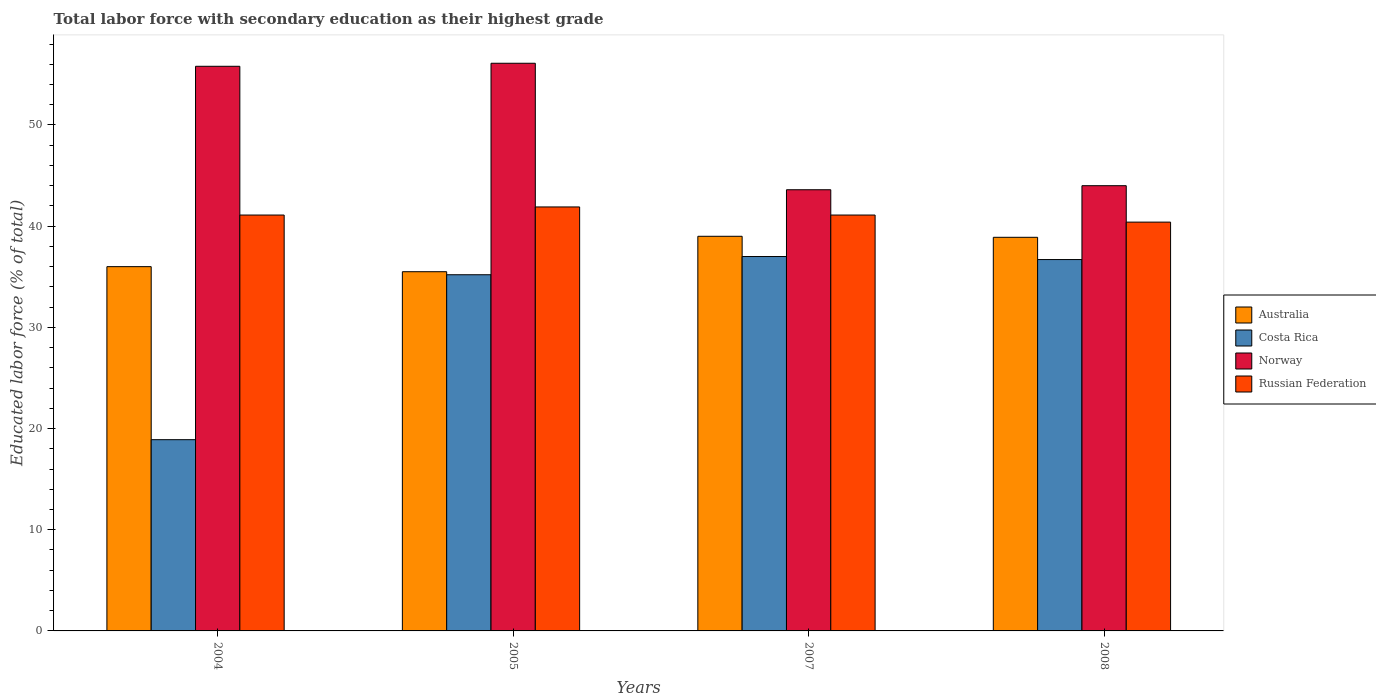How many different coloured bars are there?
Give a very brief answer. 4. How many groups of bars are there?
Provide a succinct answer. 4. Are the number of bars per tick equal to the number of legend labels?
Provide a succinct answer. Yes. How many bars are there on the 3rd tick from the left?
Your answer should be very brief. 4. How many bars are there on the 1st tick from the right?
Provide a succinct answer. 4. What is the label of the 3rd group of bars from the left?
Give a very brief answer. 2007. In how many cases, is the number of bars for a given year not equal to the number of legend labels?
Offer a very short reply. 0. What is the percentage of total labor force with primary education in Australia in 2008?
Ensure brevity in your answer.  38.9. Across all years, what is the maximum percentage of total labor force with primary education in Costa Rica?
Offer a terse response. 37. Across all years, what is the minimum percentage of total labor force with primary education in Russian Federation?
Provide a short and direct response. 40.4. In which year was the percentage of total labor force with primary education in Costa Rica maximum?
Make the answer very short. 2007. What is the total percentage of total labor force with primary education in Russian Federation in the graph?
Give a very brief answer. 164.5. What is the difference between the percentage of total labor force with primary education in Costa Rica in 2004 and that in 2008?
Your answer should be very brief. -17.8. What is the difference between the percentage of total labor force with primary education in Australia in 2008 and the percentage of total labor force with primary education in Norway in 2005?
Your answer should be compact. -17.2. What is the average percentage of total labor force with primary education in Australia per year?
Give a very brief answer. 37.35. In the year 2004, what is the difference between the percentage of total labor force with primary education in Australia and percentage of total labor force with primary education in Norway?
Provide a succinct answer. -19.8. In how many years, is the percentage of total labor force with primary education in Costa Rica greater than 18 %?
Your answer should be compact. 4. What is the ratio of the percentage of total labor force with primary education in Russian Federation in 2005 to that in 2007?
Your answer should be compact. 1.02. Is the difference between the percentage of total labor force with primary education in Australia in 2005 and 2008 greater than the difference between the percentage of total labor force with primary education in Norway in 2005 and 2008?
Offer a terse response. No. What is the difference between the highest and the second highest percentage of total labor force with primary education in Russian Federation?
Give a very brief answer. 0.8. What is the difference between the highest and the lowest percentage of total labor force with primary education in Norway?
Your response must be concise. 12.5. In how many years, is the percentage of total labor force with primary education in Australia greater than the average percentage of total labor force with primary education in Australia taken over all years?
Ensure brevity in your answer.  2. Is the sum of the percentage of total labor force with primary education in Norway in 2004 and 2005 greater than the maximum percentage of total labor force with primary education in Australia across all years?
Ensure brevity in your answer.  Yes. Is it the case that in every year, the sum of the percentage of total labor force with primary education in Australia and percentage of total labor force with primary education in Russian Federation is greater than the sum of percentage of total labor force with primary education in Costa Rica and percentage of total labor force with primary education in Norway?
Provide a short and direct response. No. What does the 3rd bar from the left in 2008 represents?
Keep it short and to the point. Norway. What does the 1st bar from the right in 2007 represents?
Give a very brief answer. Russian Federation. Is it the case that in every year, the sum of the percentage of total labor force with primary education in Costa Rica and percentage of total labor force with primary education in Australia is greater than the percentage of total labor force with primary education in Norway?
Make the answer very short. No. How many bars are there?
Keep it short and to the point. 16. How many years are there in the graph?
Offer a very short reply. 4. What is the difference between two consecutive major ticks on the Y-axis?
Your response must be concise. 10. Does the graph contain any zero values?
Offer a terse response. No. Does the graph contain grids?
Make the answer very short. No. Where does the legend appear in the graph?
Keep it short and to the point. Center right. How many legend labels are there?
Your response must be concise. 4. How are the legend labels stacked?
Offer a very short reply. Vertical. What is the title of the graph?
Your answer should be compact. Total labor force with secondary education as their highest grade. What is the label or title of the X-axis?
Offer a very short reply. Years. What is the label or title of the Y-axis?
Your response must be concise. Educated labor force (% of total). What is the Educated labor force (% of total) in Costa Rica in 2004?
Your answer should be compact. 18.9. What is the Educated labor force (% of total) in Norway in 2004?
Keep it short and to the point. 55.8. What is the Educated labor force (% of total) of Russian Federation in 2004?
Your answer should be compact. 41.1. What is the Educated labor force (% of total) in Australia in 2005?
Offer a terse response. 35.5. What is the Educated labor force (% of total) of Costa Rica in 2005?
Your answer should be very brief. 35.2. What is the Educated labor force (% of total) in Norway in 2005?
Give a very brief answer. 56.1. What is the Educated labor force (% of total) of Russian Federation in 2005?
Offer a terse response. 41.9. What is the Educated labor force (% of total) in Norway in 2007?
Give a very brief answer. 43.6. What is the Educated labor force (% of total) in Russian Federation in 2007?
Give a very brief answer. 41.1. What is the Educated labor force (% of total) in Australia in 2008?
Your response must be concise. 38.9. What is the Educated labor force (% of total) in Costa Rica in 2008?
Provide a short and direct response. 36.7. What is the Educated labor force (% of total) in Norway in 2008?
Offer a terse response. 44. What is the Educated labor force (% of total) in Russian Federation in 2008?
Offer a terse response. 40.4. Across all years, what is the maximum Educated labor force (% of total) of Australia?
Offer a very short reply. 39. Across all years, what is the maximum Educated labor force (% of total) in Norway?
Keep it short and to the point. 56.1. Across all years, what is the maximum Educated labor force (% of total) of Russian Federation?
Your response must be concise. 41.9. Across all years, what is the minimum Educated labor force (% of total) of Australia?
Make the answer very short. 35.5. Across all years, what is the minimum Educated labor force (% of total) of Costa Rica?
Keep it short and to the point. 18.9. Across all years, what is the minimum Educated labor force (% of total) in Norway?
Your response must be concise. 43.6. Across all years, what is the minimum Educated labor force (% of total) in Russian Federation?
Provide a succinct answer. 40.4. What is the total Educated labor force (% of total) of Australia in the graph?
Your answer should be compact. 149.4. What is the total Educated labor force (% of total) of Costa Rica in the graph?
Provide a succinct answer. 127.8. What is the total Educated labor force (% of total) in Norway in the graph?
Ensure brevity in your answer.  199.5. What is the total Educated labor force (% of total) of Russian Federation in the graph?
Provide a succinct answer. 164.5. What is the difference between the Educated labor force (% of total) of Australia in 2004 and that in 2005?
Make the answer very short. 0.5. What is the difference between the Educated labor force (% of total) in Costa Rica in 2004 and that in 2005?
Give a very brief answer. -16.3. What is the difference between the Educated labor force (% of total) of Norway in 2004 and that in 2005?
Make the answer very short. -0.3. What is the difference between the Educated labor force (% of total) in Australia in 2004 and that in 2007?
Provide a short and direct response. -3. What is the difference between the Educated labor force (% of total) of Costa Rica in 2004 and that in 2007?
Give a very brief answer. -18.1. What is the difference between the Educated labor force (% of total) of Norway in 2004 and that in 2007?
Offer a terse response. 12.2. What is the difference between the Educated labor force (% of total) in Russian Federation in 2004 and that in 2007?
Keep it short and to the point. 0. What is the difference between the Educated labor force (% of total) in Australia in 2004 and that in 2008?
Keep it short and to the point. -2.9. What is the difference between the Educated labor force (% of total) in Costa Rica in 2004 and that in 2008?
Ensure brevity in your answer.  -17.8. What is the difference between the Educated labor force (% of total) in Russian Federation in 2004 and that in 2008?
Provide a succinct answer. 0.7. What is the difference between the Educated labor force (% of total) in Costa Rica in 2005 and that in 2007?
Offer a terse response. -1.8. What is the difference between the Educated labor force (% of total) in Russian Federation in 2005 and that in 2007?
Your answer should be very brief. 0.8. What is the difference between the Educated labor force (% of total) of Australia in 2007 and that in 2008?
Offer a very short reply. 0.1. What is the difference between the Educated labor force (% of total) of Russian Federation in 2007 and that in 2008?
Offer a terse response. 0.7. What is the difference between the Educated labor force (% of total) in Australia in 2004 and the Educated labor force (% of total) in Norway in 2005?
Offer a very short reply. -20.1. What is the difference between the Educated labor force (% of total) in Australia in 2004 and the Educated labor force (% of total) in Russian Federation in 2005?
Give a very brief answer. -5.9. What is the difference between the Educated labor force (% of total) of Costa Rica in 2004 and the Educated labor force (% of total) of Norway in 2005?
Provide a succinct answer. -37.2. What is the difference between the Educated labor force (% of total) in Costa Rica in 2004 and the Educated labor force (% of total) in Russian Federation in 2005?
Offer a very short reply. -23. What is the difference between the Educated labor force (% of total) of Norway in 2004 and the Educated labor force (% of total) of Russian Federation in 2005?
Your answer should be very brief. 13.9. What is the difference between the Educated labor force (% of total) in Costa Rica in 2004 and the Educated labor force (% of total) in Norway in 2007?
Offer a very short reply. -24.7. What is the difference between the Educated labor force (% of total) in Costa Rica in 2004 and the Educated labor force (% of total) in Russian Federation in 2007?
Your response must be concise. -22.2. What is the difference between the Educated labor force (% of total) of Australia in 2004 and the Educated labor force (% of total) of Russian Federation in 2008?
Offer a terse response. -4.4. What is the difference between the Educated labor force (% of total) in Costa Rica in 2004 and the Educated labor force (% of total) in Norway in 2008?
Your answer should be compact. -25.1. What is the difference between the Educated labor force (% of total) in Costa Rica in 2004 and the Educated labor force (% of total) in Russian Federation in 2008?
Your answer should be compact. -21.5. What is the difference between the Educated labor force (% of total) of Australia in 2005 and the Educated labor force (% of total) of Russian Federation in 2007?
Your response must be concise. -5.6. What is the difference between the Educated labor force (% of total) in Costa Rica in 2005 and the Educated labor force (% of total) in Norway in 2007?
Provide a succinct answer. -8.4. What is the difference between the Educated labor force (% of total) in Australia in 2005 and the Educated labor force (% of total) in Norway in 2008?
Offer a terse response. -8.5. What is the difference between the Educated labor force (% of total) in Australia in 2005 and the Educated labor force (% of total) in Russian Federation in 2008?
Provide a short and direct response. -4.9. What is the difference between the Educated labor force (% of total) in Australia in 2007 and the Educated labor force (% of total) in Costa Rica in 2008?
Ensure brevity in your answer.  2.3. What is the difference between the Educated labor force (% of total) of Australia in 2007 and the Educated labor force (% of total) of Russian Federation in 2008?
Provide a short and direct response. -1.4. What is the difference between the Educated labor force (% of total) in Costa Rica in 2007 and the Educated labor force (% of total) in Norway in 2008?
Offer a terse response. -7. What is the difference between the Educated labor force (% of total) of Costa Rica in 2007 and the Educated labor force (% of total) of Russian Federation in 2008?
Ensure brevity in your answer.  -3.4. What is the difference between the Educated labor force (% of total) of Norway in 2007 and the Educated labor force (% of total) of Russian Federation in 2008?
Offer a very short reply. 3.2. What is the average Educated labor force (% of total) in Australia per year?
Ensure brevity in your answer.  37.35. What is the average Educated labor force (% of total) in Costa Rica per year?
Your answer should be compact. 31.95. What is the average Educated labor force (% of total) in Norway per year?
Ensure brevity in your answer.  49.88. What is the average Educated labor force (% of total) in Russian Federation per year?
Give a very brief answer. 41.12. In the year 2004, what is the difference between the Educated labor force (% of total) in Australia and Educated labor force (% of total) in Norway?
Provide a short and direct response. -19.8. In the year 2004, what is the difference between the Educated labor force (% of total) in Costa Rica and Educated labor force (% of total) in Norway?
Offer a very short reply. -36.9. In the year 2004, what is the difference between the Educated labor force (% of total) in Costa Rica and Educated labor force (% of total) in Russian Federation?
Your response must be concise. -22.2. In the year 2004, what is the difference between the Educated labor force (% of total) in Norway and Educated labor force (% of total) in Russian Federation?
Your response must be concise. 14.7. In the year 2005, what is the difference between the Educated labor force (% of total) of Australia and Educated labor force (% of total) of Norway?
Provide a succinct answer. -20.6. In the year 2005, what is the difference between the Educated labor force (% of total) in Australia and Educated labor force (% of total) in Russian Federation?
Offer a very short reply. -6.4. In the year 2005, what is the difference between the Educated labor force (% of total) in Costa Rica and Educated labor force (% of total) in Norway?
Your answer should be compact. -20.9. In the year 2007, what is the difference between the Educated labor force (% of total) of Australia and Educated labor force (% of total) of Norway?
Provide a short and direct response. -4.6. In the year 2007, what is the difference between the Educated labor force (% of total) in Australia and Educated labor force (% of total) in Russian Federation?
Offer a very short reply. -2.1. In the year 2007, what is the difference between the Educated labor force (% of total) in Norway and Educated labor force (% of total) in Russian Federation?
Provide a succinct answer. 2.5. In the year 2008, what is the difference between the Educated labor force (% of total) of Australia and Educated labor force (% of total) of Norway?
Your answer should be compact. -5.1. In the year 2008, what is the difference between the Educated labor force (% of total) of Costa Rica and Educated labor force (% of total) of Norway?
Keep it short and to the point. -7.3. In the year 2008, what is the difference between the Educated labor force (% of total) of Costa Rica and Educated labor force (% of total) of Russian Federation?
Offer a very short reply. -3.7. What is the ratio of the Educated labor force (% of total) of Australia in 2004 to that in 2005?
Your response must be concise. 1.01. What is the ratio of the Educated labor force (% of total) in Costa Rica in 2004 to that in 2005?
Your answer should be compact. 0.54. What is the ratio of the Educated labor force (% of total) in Norway in 2004 to that in 2005?
Provide a succinct answer. 0.99. What is the ratio of the Educated labor force (% of total) of Russian Federation in 2004 to that in 2005?
Keep it short and to the point. 0.98. What is the ratio of the Educated labor force (% of total) in Costa Rica in 2004 to that in 2007?
Give a very brief answer. 0.51. What is the ratio of the Educated labor force (% of total) in Norway in 2004 to that in 2007?
Your response must be concise. 1.28. What is the ratio of the Educated labor force (% of total) of Russian Federation in 2004 to that in 2007?
Your answer should be very brief. 1. What is the ratio of the Educated labor force (% of total) of Australia in 2004 to that in 2008?
Give a very brief answer. 0.93. What is the ratio of the Educated labor force (% of total) in Costa Rica in 2004 to that in 2008?
Give a very brief answer. 0.52. What is the ratio of the Educated labor force (% of total) in Norway in 2004 to that in 2008?
Offer a terse response. 1.27. What is the ratio of the Educated labor force (% of total) in Russian Federation in 2004 to that in 2008?
Give a very brief answer. 1.02. What is the ratio of the Educated labor force (% of total) of Australia in 2005 to that in 2007?
Provide a succinct answer. 0.91. What is the ratio of the Educated labor force (% of total) in Costa Rica in 2005 to that in 2007?
Ensure brevity in your answer.  0.95. What is the ratio of the Educated labor force (% of total) of Norway in 2005 to that in 2007?
Offer a terse response. 1.29. What is the ratio of the Educated labor force (% of total) in Russian Federation in 2005 to that in 2007?
Ensure brevity in your answer.  1.02. What is the ratio of the Educated labor force (% of total) in Australia in 2005 to that in 2008?
Offer a very short reply. 0.91. What is the ratio of the Educated labor force (% of total) of Costa Rica in 2005 to that in 2008?
Your response must be concise. 0.96. What is the ratio of the Educated labor force (% of total) in Norway in 2005 to that in 2008?
Your answer should be compact. 1.27. What is the ratio of the Educated labor force (% of total) in Russian Federation in 2005 to that in 2008?
Your answer should be very brief. 1.04. What is the ratio of the Educated labor force (% of total) of Costa Rica in 2007 to that in 2008?
Give a very brief answer. 1.01. What is the ratio of the Educated labor force (% of total) in Norway in 2007 to that in 2008?
Provide a succinct answer. 0.99. What is the ratio of the Educated labor force (% of total) of Russian Federation in 2007 to that in 2008?
Keep it short and to the point. 1.02. What is the difference between the highest and the second highest Educated labor force (% of total) of Russian Federation?
Make the answer very short. 0.8. What is the difference between the highest and the lowest Educated labor force (% of total) in Australia?
Your answer should be compact. 3.5. What is the difference between the highest and the lowest Educated labor force (% of total) in Costa Rica?
Ensure brevity in your answer.  18.1. What is the difference between the highest and the lowest Educated labor force (% of total) of Norway?
Provide a succinct answer. 12.5. 